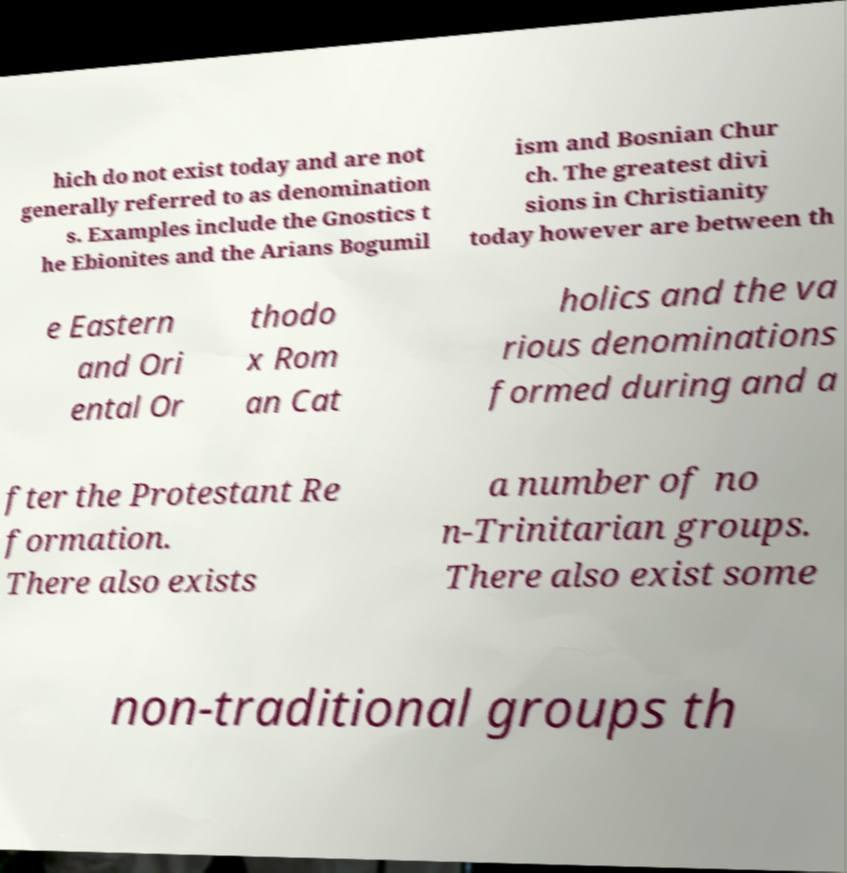Can you read and provide the text displayed in the image?This photo seems to have some interesting text. Can you extract and type it out for me? hich do not exist today and are not generally referred to as denomination s. Examples include the Gnostics t he Ebionites and the Arians Bogumil ism and Bosnian Chur ch. The greatest divi sions in Christianity today however are between th e Eastern and Ori ental Or thodo x Rom an Cat holics and the va rious denominations formed during and a fter the Protestant Re formation. There also exists a number of no n-Trinitarian groups. There also exist some non-traditional groups th 